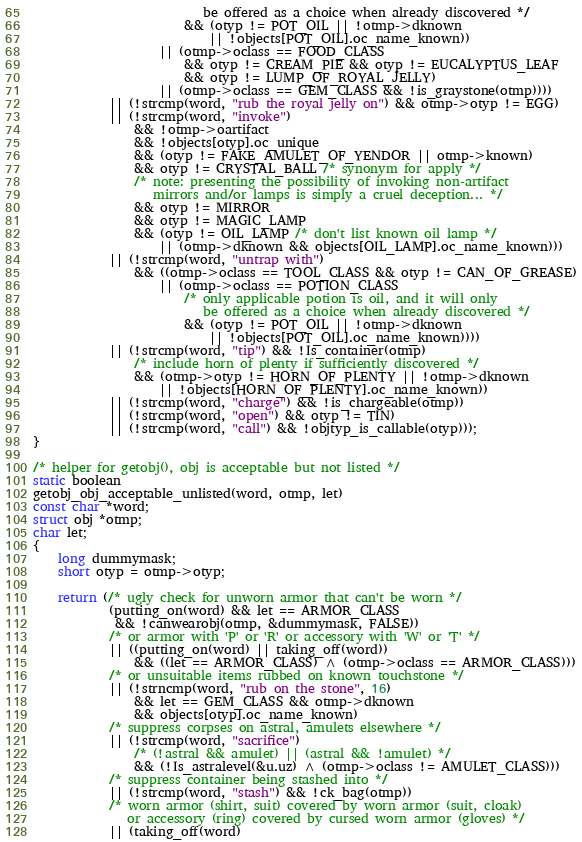<code> <loc_0><loc_0><loc_500><loc_500><_C_>                           be offered as a choice when already discovered */
                        && (otyp != POT_OIL || !otmp->dknown
                            || !objects[POT_OIL].oc_name_known))
                    || (otmp->oclass == FOOD_CLASS
                        && otyp != CREAM_PIE && otyp != EUCALYPTUS_LEAF
                        && otyp != LUMP_OF_ROYAL_JELLY)
                    || (otmp->oclass == GEM_CLASS && !is_graystone(otmp))))
            || (!strcmp(word, "rub the royal jelly on") && otmp->otyp != EGG)
            || (!strcmp(word, "invoke")
                && !otmp->oartifact
                && !objects[otyp].oc_unique
                && (otyp != FAKE_AMULET_OF_YENDOR || otmp->known)
                && otyp != CRYSTAL_BALL /* synonym for apply */
                /* note: presenting the possibility of invoking non-artifact
                   mirrors and/or lamps is simply a cruel deception... */
                && otyp != MIRROR
                && otyp != MAGIC_LAMP
                && (otyp != OIL_LAMP /* don't list known oil lamp */
                    || (otmp->dknown && objects[OIL_LAMP].oc_name_known)))
            || (!strcmp(word, "untrap with")
                && ((otmp->oclass == TOOL_CLASS && otyp != CAN_OF_GREASE)
                    || (otmp->oclass == POTION_CLASS
                        /* only applicable potion is oil, and it will only
                           be offered as a choice when already discovered */
                        && (otyp != POT_OIL || !otmp->dknown
                            || !objects[POT_OIL].oc_name_known))))
            || (!strcmp(word, "tip") && !Is_container(otmp)
                /* include horn of plenty if sufficiently discovered */
                && (otmp->otyp != HORN_OF_PLENTY || !otmp->dknown
                    || !objects[HORN_OF_PLENTY].oc_name_known))
            || (!strcmp(word, "charge") && !is_chargeable(otmp))
            || (!strcmp(word, "open") && otyp != TIN)
            || (!strcmp(word, "call") && !objtyp_is_callable(otyp)));
}

/* helper for getobj(), obj is acceptable but not listed */
static boolean
getobj_obj_acceptable_unlisted(word, otmp, let)
const char *word;
struct obj *otmp;
char let;
{
    long dummymask;
    short otyp = otmp->otyp;

    return (/* ugly check for unworn armor that can't be worn */
            (putting_on(word) && let == ARMOR_CLASS
             && !canwearobj(otmp, &dummymask, FALSE))
            /* or armor with 'P' or 'R' or accessory with 'W' or 'T' */
            || ((putting_on(word) || taking_off(word))
                && ((let == ARMOR_CLASS) ^ (otmp->oclass == ARMOR_CLASS)))
            /* or unsuitable items rubbed on known touchstone */
            || (!strncmp(word, "rub on the stone", 16)
                && let == GEM_CLASS && otmp->dknown
                && objects[otyp].oc_name_known)
            /* suppress corpses on astral, amulets elsewhere */
            || (!strcmp(word, "sacrifice")
                /* (!astral && amulet) || (astral && !amulet) */
                && (!Is_astralevel(&u.uz) ^ (otmp->oclass != AMULET_CLASS)))
            /* suppress container being stashed into */
            || (!strcmp(word, "stash") && !ck_bag(otmp))
            /* worn armor (shirt, suit) covered by worn armor (suit, cloak)
               or accessory (ring) covered by cursed worn armor (gloves) */
            || (taking_off(word)</code> 